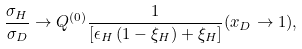<formula> <loc_0><loc_0><loc_500><loc_500>\frac { \sigma _ { H } } { \sigma _ { D } } \rightarrow Q ^ { ( 0 ) } \frac { 1 } { \left [ \epsilon _ { H } \left ( 1 - \xi _ { H } \right ) + \xi _ { H } \right ] } ( x _ { D } \rightarrow 1 ) ,</formula> 